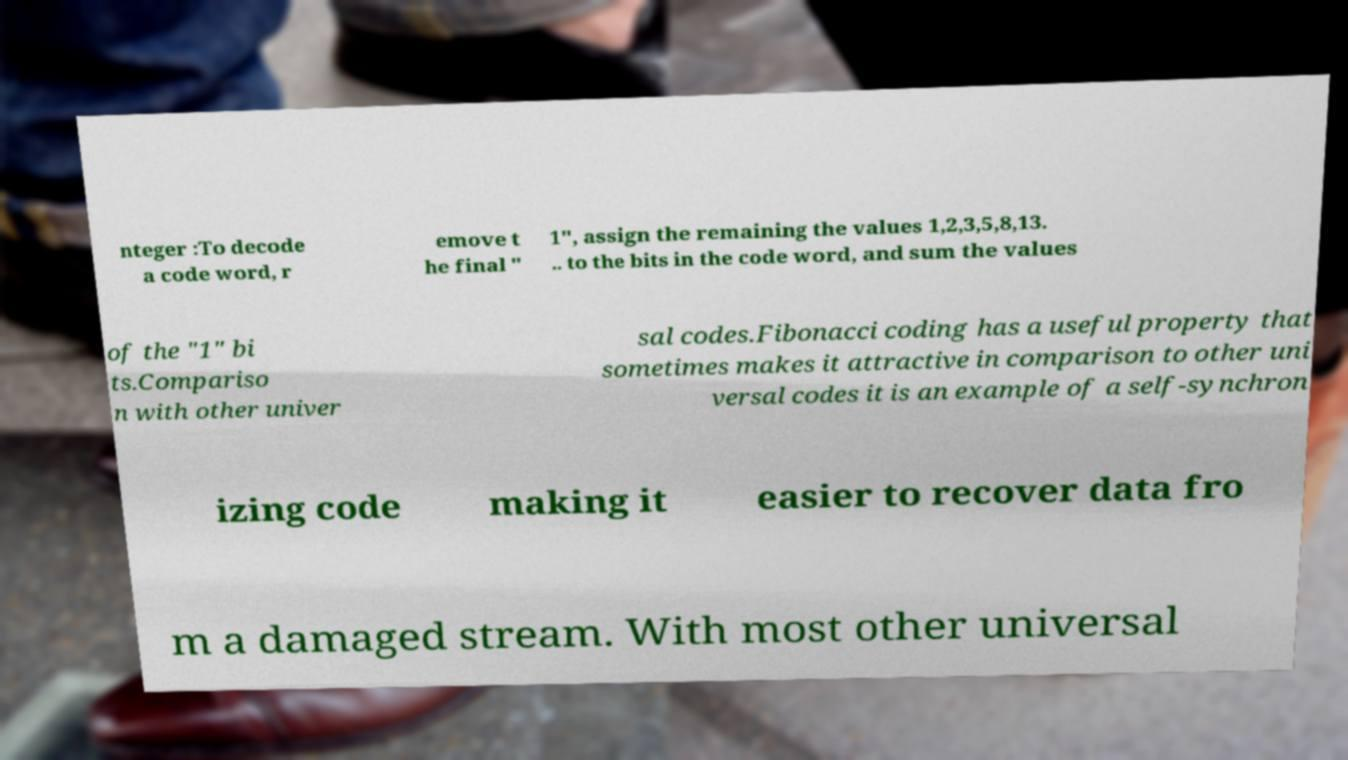I need the written content from this picture converted into text. Can you do that? nteger :To decode a code word, r emove t he final " 1", assign the remaining the values 1,2,3,5,8,13. .. to the bits in the code word, and sum the values of the "1" bi ts.Compariso n with other univer sal codes.Fibonacci coding has a useful property that sometimes makes it attractive in comparison to other uni versal codes it is an example of a self-synchron izing code making it easier to recover data fro m a damaged stream. With most other universal 